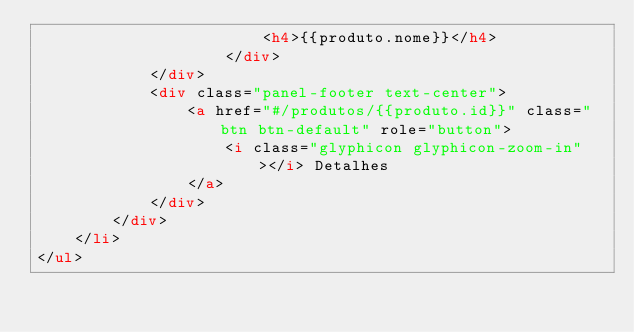<code> <loc_0><loc_0><loc_500><loc_500><_HTML_>                        <h4>{{produto.nome}}</h4>
                    </div>
            </div>
            <div class="panel-footer text-center">
                <a href="#/produtos/{{produto.id}}" class="btn btn-default" role="button">
                    <i class="glyphicon glyphicon-zoom-in"></i> Detalhes
                </a>
            </div>
        </div>
    </li>
</ul>
</code> 